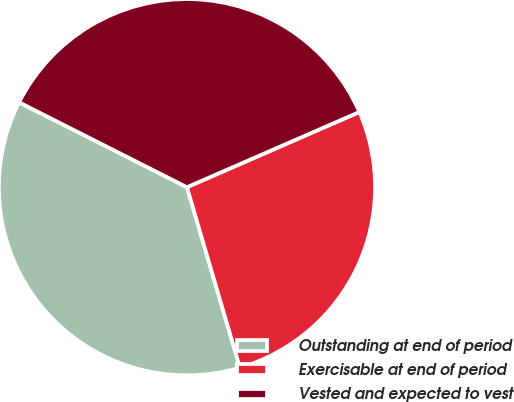<chart> <loc_0><loc_0><loc_500><loc_500><pie_chart><fcel>Outstanding at end of period<fcel>Exercisable at end of period<fcel>Vested and expected to vest<nl><fcel>36.99%<fcel>27.0%<fcel>36.0%<nl></chart> 